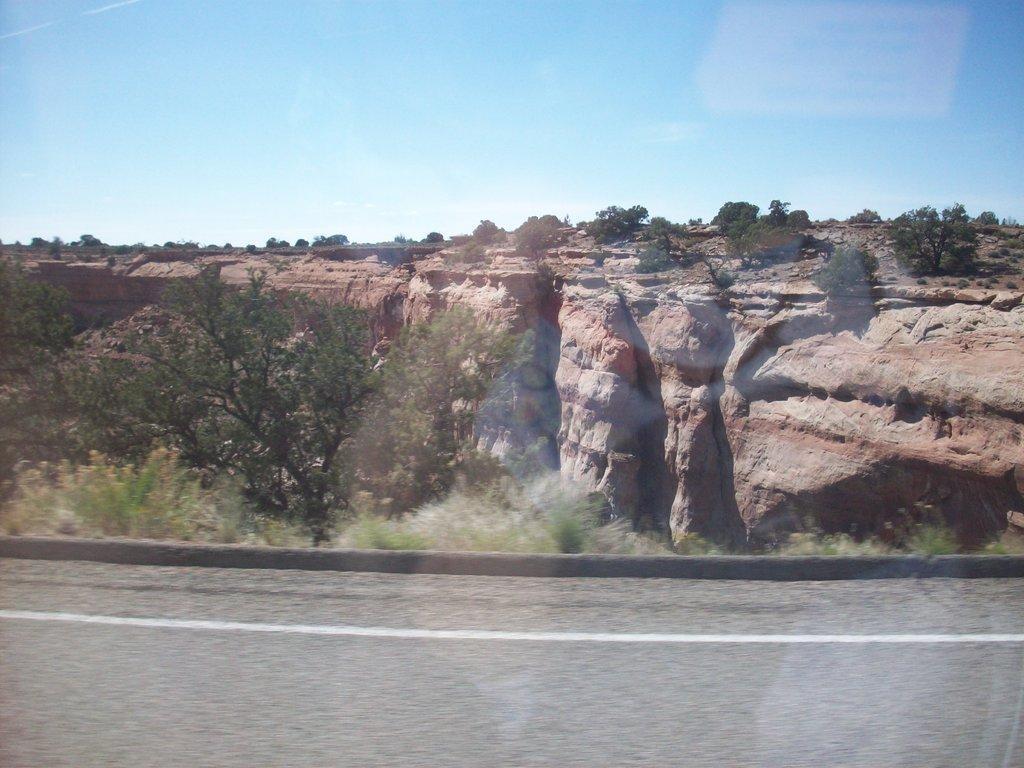In one or two sentences, can you explain what this image depicts? In this image there is a road. Beside there are few plants and trees on the land. Behind there is a hill having few trees on it. Top of image there is sky. 